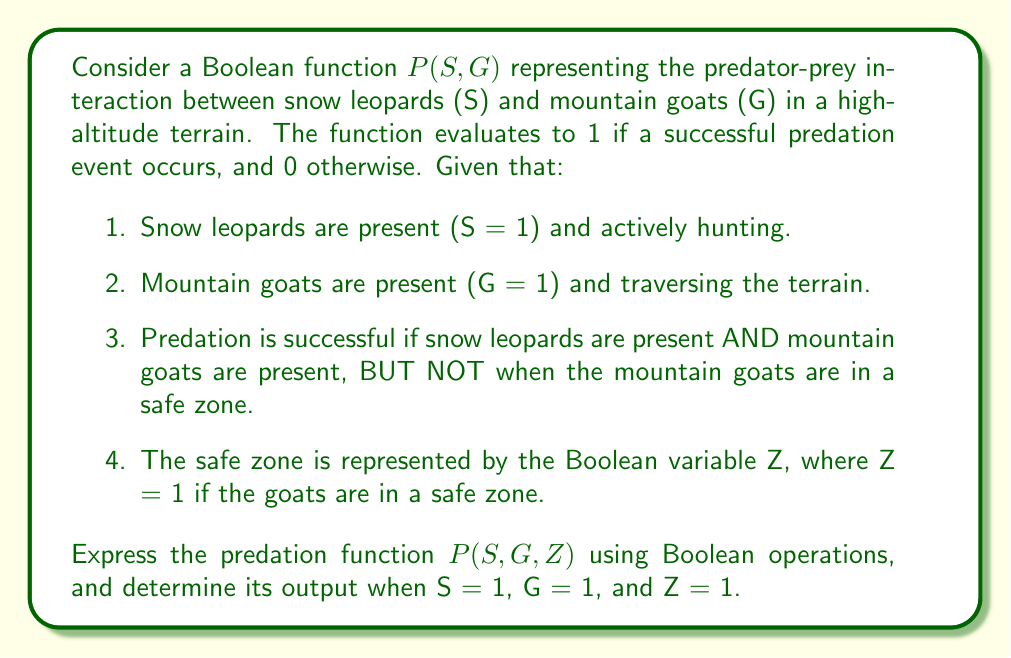Could you help me with this problem? Let's approach this step-by-step:

1. First, we need to express the conditions for a successful predation event in Boolean terms:
   - Snow leopards are present: S = 1
   - Mountain goats are present: G = 1
   - Goats are not in a safe zone: Z = 0 (or NOT Z)

2. The predation function P(S, G, Z) should be true (1) when all these conditions are met simultaneously. We can express this using the AND operation (∧):

   $$P(S, G, Z) = S \wedge G \wedge \neg Z$$

   Here, $\neg Z$ represents the NOT operation on Z.

3. We can also write this using Boolean algebra notation:

   $$P(S, G, Z) = S \cdot G \cdot \overline{Z}$$

4. Now, let's evaluate the function for the given values:
   S = 1, G = 1, Z = 1

5. Substituting these values into our function:

   $$P(1, 1, 1) = 1 \wedge 1 \wedge \neg 1$$
   $$= 1 \wedge 1 \wedge 0$$
   $$= 0$$

6. The result is 0, indicating that no successful predation occurs when the mountain goats are in a safe zone, even if both snow leopards and mountain goats are present.
Answer: $$P(S, G, Z) = S \wedge G \wedge \neg Z = 0$$ 